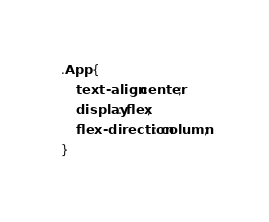Convert code to text. <code><loc_0><loc_0><loc_500><loc_500><_CSS_>.App {
	text-align: center;
	display: flex;
	flex-direction: column;
}
</code> 